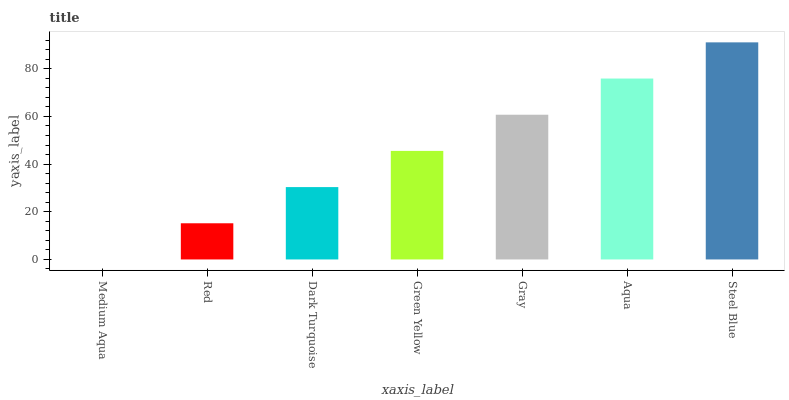Is Medium Aqua the minimum?
Answer yes or no. Yes. Is Steel Blue the maximum?
Answer yes or no. Yes. Is Red the minimum?
Answer yes or no. No. Is Red the maximum?
Answer yes or no. No. Is Red greater than Medium Aqua?
Answer yes or no. Yes. Is Medium Aqua less than Red?
Answer yes or no. Yes. Is Medium Aqua greater than Red?
Answer yes or no. No. Is Red less than Medium Aqua?
Answer yes or no. No. Is Green Yellow the high median?
Answer yes or no. Yes. Is Green Yellow the low median?
Answer yes or no. Yes. Is Gray the high median?
Answer yes or no. No. Is Gray the low median?
Answer yes or no. No. 